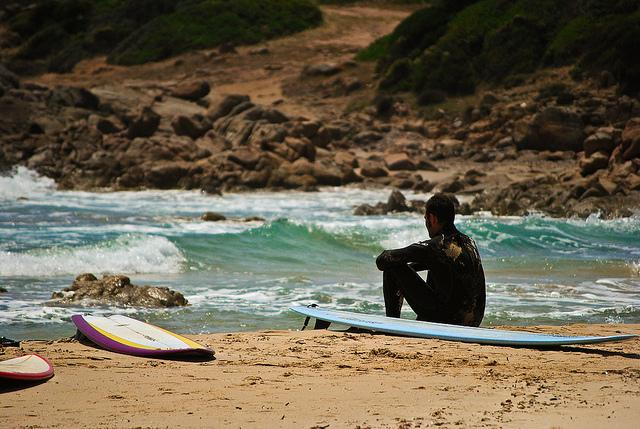What was the man just doing? surfing 